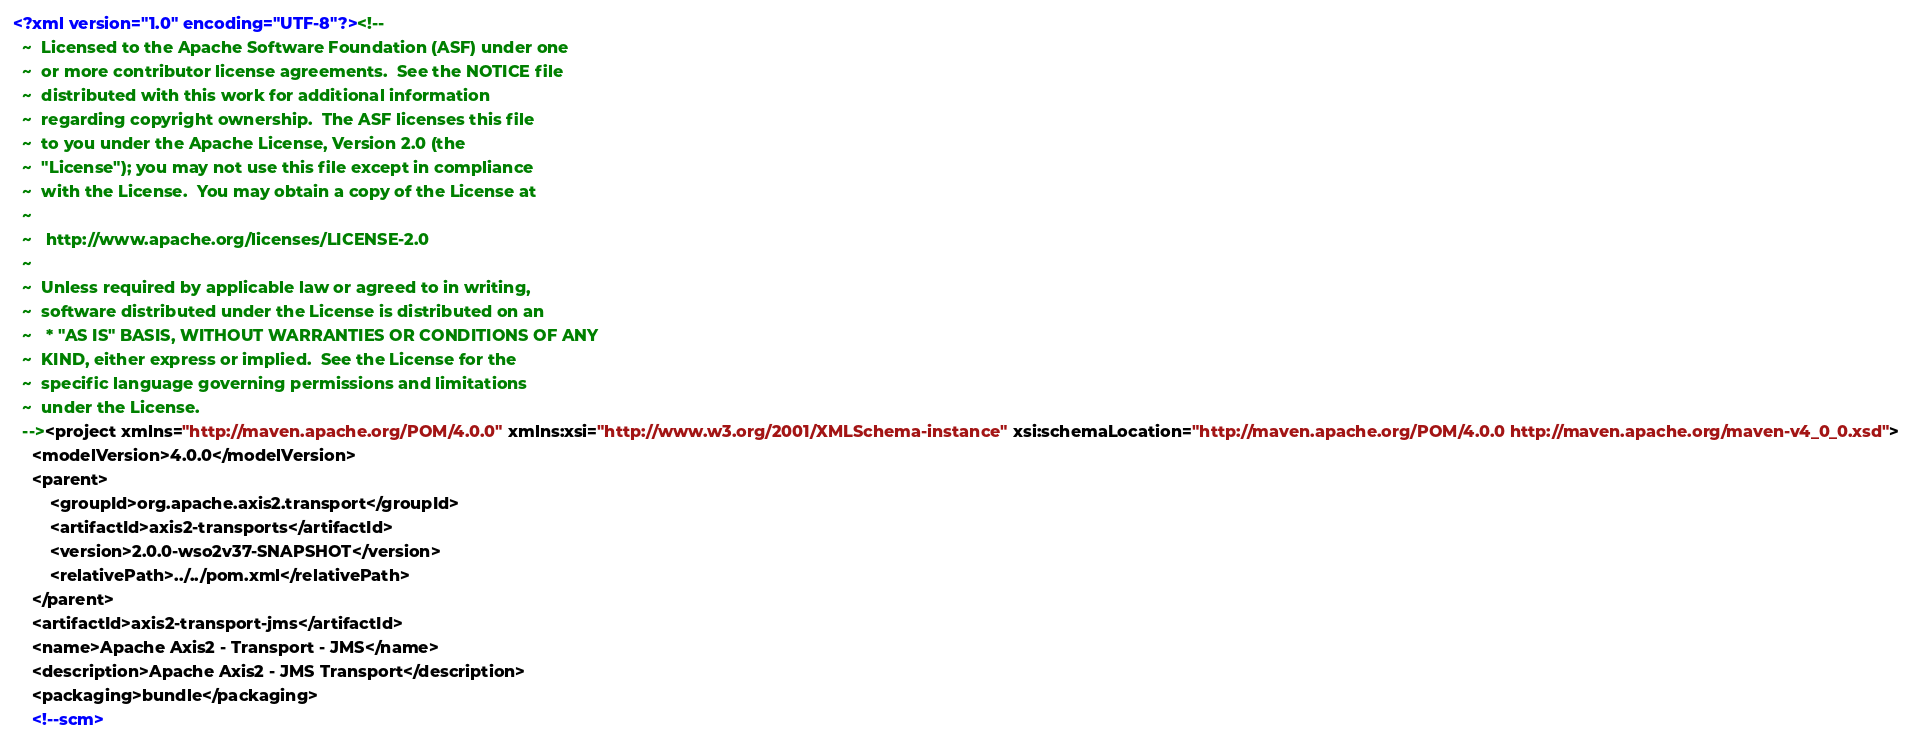<code> <loc_0><loc_0><loc_500><loc_500><_XML_><?xml version="1.0" encoding="UTF-8"?><!--
  ~  Licensed to the Apache Software Foundation (ASF) under one
  ~  or more contributor license agreements.  See the NOTICE file
  ~  distributed with this work for additional information
  ~  regarding copyright ownership.  The ASF licenses this file
  ~  to you under the Apache License, Version 2.0 (the
  ~  "License"); you may not use this file except in compliance
  ~  with the License.  You may obtain a copy of the License at
  ~
  ~   http://www.apache.org/licenses/LICENSE-2.0
  ~
  ~  Unless required by applicable law or agreed to in writing,
  ~  software distributed under the License is distributed on an
  ~   * "AS IS" BASIS, WITHOUT WARRANTIES OR CONDITIONS OF ANY
  ~  KIND, either express or implied.  See the License for the
  ~  specific language governing permissions and limitations
  ~  under the License.
  --><project xmlns="http://maven.apache.org/POM/4.0.0" xmlns:xsi="http://www.w3.org/2001/XMLSchema-instance" xsi:schemaLocation="http://maven.apache.org/POM/4.0.0 http://maven.apache.org/maven-v4_0_0.xsd">
    <modelVersion>4.0.0</modelVersion>
    <parent>
        <groupId>org.apache.axis2.transport</groupId>
        <artifactId>axis2-transports</artifactId>
        <version>2.0.0-wso2v37-SNAPSHOT</version>
        <relativePath>../../pom.xml</relativePath>
    </parent>
    <artifactId>axis2-transport-jms</artifactId>
    <name>Apache Axis2 - Transport - JMS</name>
    <description>Apache Axis2 - JMS Transport</description>
    <packaging>bundle</packaging>
    <!--scm></code> 